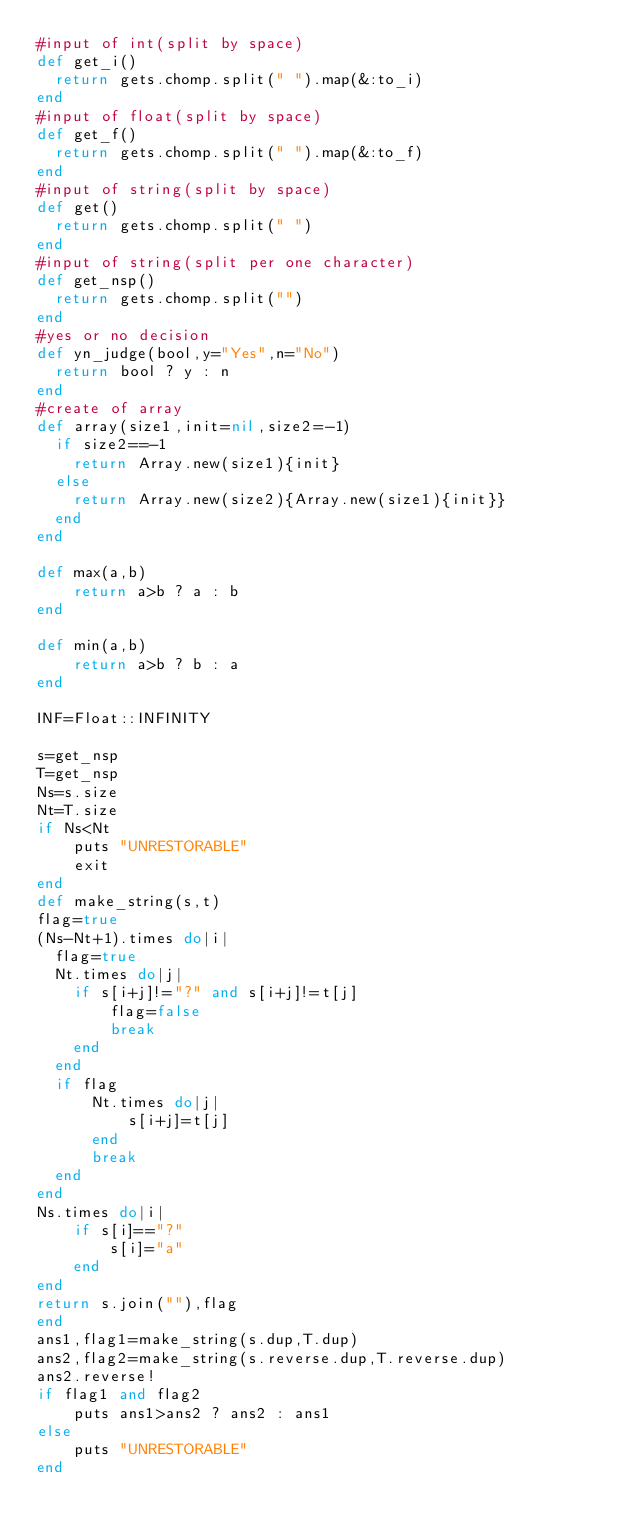<code> <loc_0><loc_0><loc_500><loc_500><_Ruby_>#input of int(split by space)
def get_i()
  return gets.chomp.split(" ").map(&:to_i)
end
#input of float(split by space)
def get_f()
  return gets.chomp.split(" ").map(&:to_f)
end
#input of string(split by space)
def get()
  return gets.chomp.split(" ")
end
#input of string(split per one character)
def get_nsp()
  return gets.chomp.split("")
end
#yes or no decision
def yn_judge(bool,y="Yes",n="No")
  return bool ? y : n 
end
#create of array
def array(size1,init=nil,size2=-1)
  if size2==-1
    return Array.new(size1){init}
  else
    return Array.new(size2){Array.new(size1){init}}
  end
end

def max(a,b)
    return a>b ? a : b
end

def min(a,b)
    return a>b ? b : a
end

INF=Float::INFINITY

s=get_nsp
T=get_nsp
Ns=s.size
Nt=T.size
if Ns<Nt
    puts "UNRESTORABLE"
    exit
end
def make_string(s,t)
flag=true
(Ns-Nt+1).times do|i|
  flag=true
  Nt.times do|j|
    if s[i+j]!="?" and s[i+j]!=t[j]
        flag=false
        break
    end
  end
  if flag
      Nt.times do|j|
          s[i+j]=t[j]
      end
      break
  end
end
Ns.times do|i|
    if s[i]=="?"
        s[i]="a"
    end
end
return s.join(""),flag
end
ans1,flag1=make_string(s.dup,T.dup)
ans2,flag2=make_string(s.reverse.dup,T.reverse.dup)
ans2.reverse!
if flag1 and flag2
    puts ans1>ans2 ? ans2 : ans1
else
    puts "UNRESTORABLE"
end</code> 